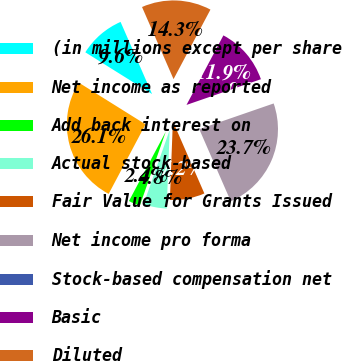Convert chart to OTSL. <chart><loc_0><loc_0><loc_500><loc_500><pie_chart><fcel>(in millions except per share<fcel>Net income as reported<fcel>Add back interest on<fcel>Actual stock-based<fcel>Fair Value for Grants Issued<fcel>Net income pro forma<fcel>Stock-based compensation net<fcel>Basic<fcel>Diluted<nl><fcel>9.55%<fcel>26.13%<fcel>2.39%<fcel>4.77%<fcel>7.16%<fcel>23.74%<fcel>0.0%<fcel>11.94%<fcel>14.32%<nl></chart> 